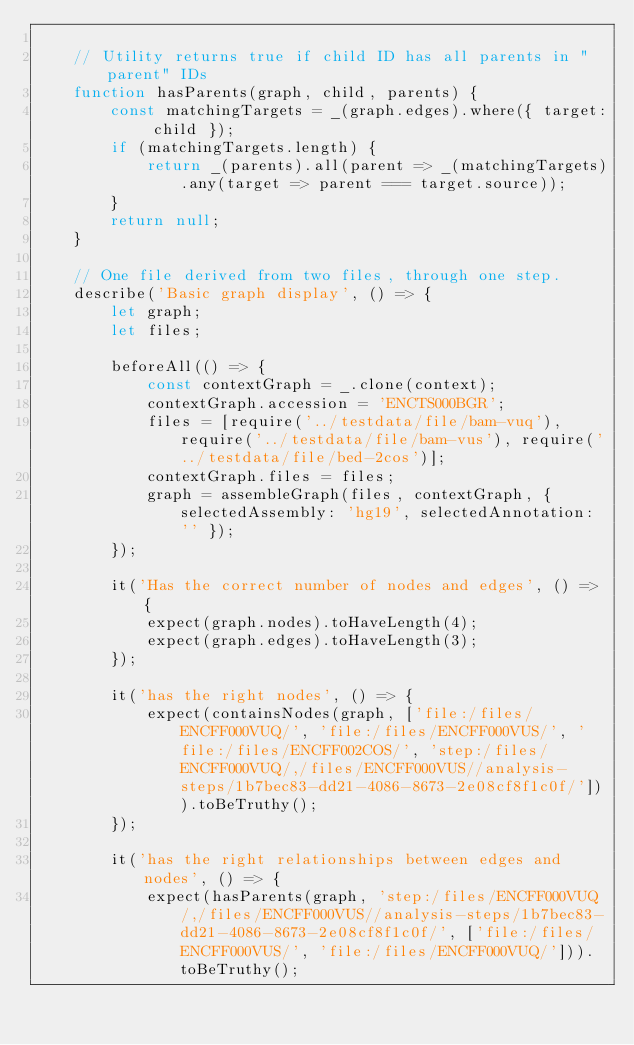Convert code to text. <code><loc_0><loc_0><loc_500><loc_500><_JavaScript_>
    // Utility returns true if child ID has all parents in "parent" IDs
    function hasParents(graph, child, parents) {
        const matchingTargets = _(graph.edges).where({ target: child });
        if (matchingTargets.length) {
            return _(parents).all(parent => _(matchingTargets).any(target => parent === target.source));
        }
        return null;
    }

    // One file derived from two files, through one step.
    describe('Basic graph display', () => {
        let graph;
        let files;

        beforeAll(() => {
            const contextGraph = _.clone(context);
            contextGraph.accession = 'ENCTS000BGR';
            files = [require('../testdata/file/bam-vuq'), require('../testdata/file/bam-vus'), require('../testdata/file/bed-2cos')];
            contextGraph.files = files;
            graph = assembleGraph(files, contextGraph, { selectedAssembly: 'hg19', selectedAnnotation: '' });
        });

        it('Has the correct number of nodes and edges', () => {
            expect(graph.nodes).toHaveLength(4);
            expect(graph.edges).toHaveLength(3);
        });

        it('has the right nodes', () => {
            expect(containsNodes(graph, ['file:/files/ENCFF000VUQ/', 'file:/files/ENCFF000VUS/', 'file:/files/ENCFF002COS/', 'step:/files/ENCFF000VUQ/,/files/ENCFF000VUS//analysis-steps/1b7bec83-dd21-4086-8673-2e08cf8f1c0f/'])).toBeTruthy();
        });

        it('has the right relationships between edges and nodes', () => {
            expect(hasParents(graph, 'step:/files/ENCFF000VUQ/,/files/ENCFF000VUS//analysis-steps/1b7bec83-dd21-4086-8673-2e08cf8f1c0f/', ['file:/files/ENCFF000VUS/', 'file:/files/ENCFF000VUQ/'])).toBeTruthy();</code> 